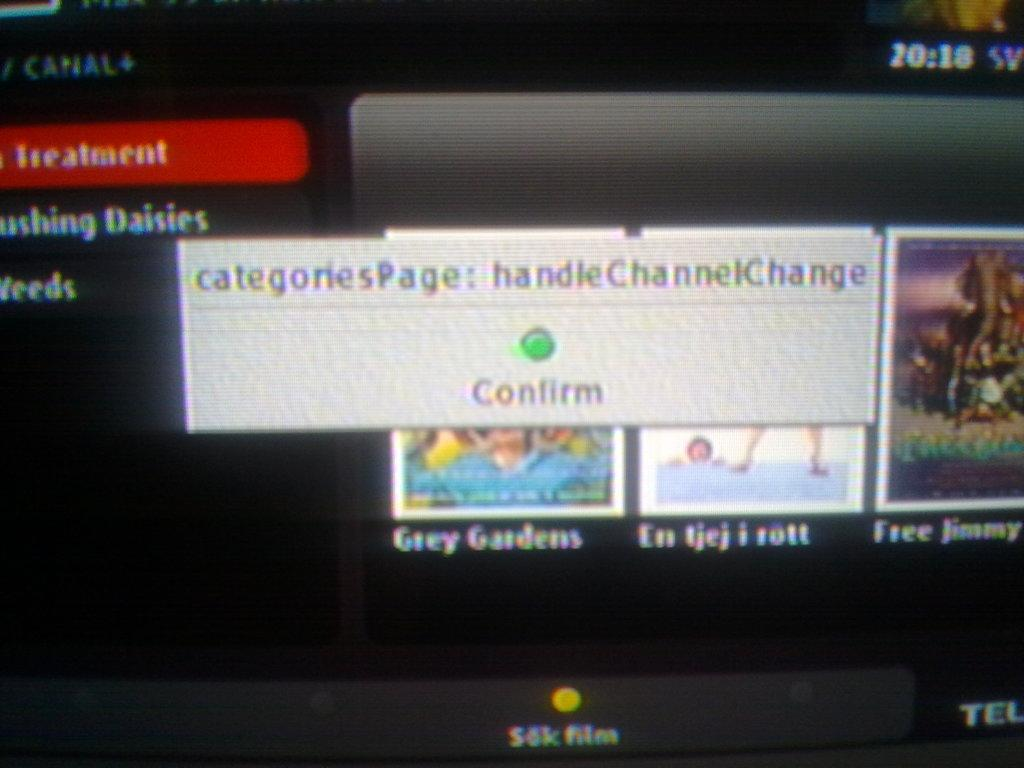<image>
Present a compact description of the photo's key features. The web page is looking for a confirmation. 